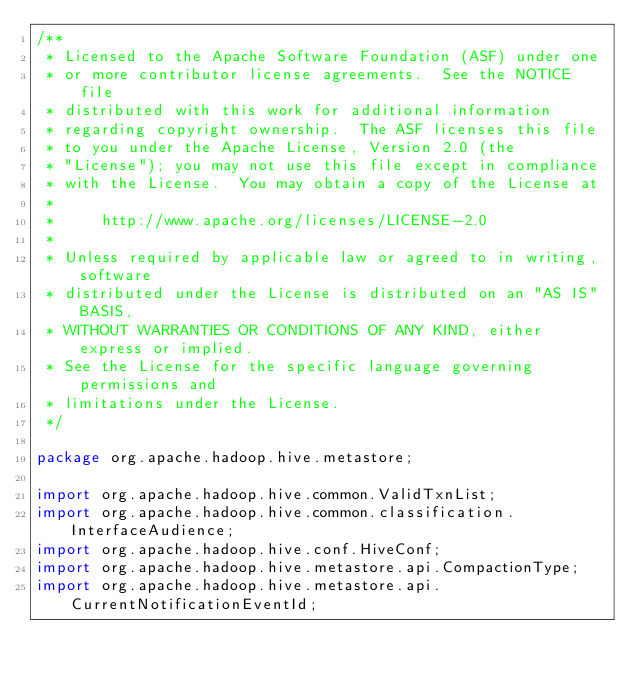Convert code to text. <code><loc_0><loc_0><loc_500><loc_500><_Java_>/**
 * Licensed to the Apache Software Foundation (ASF) under one
 * or more contributor license agreements.  See the NOTICE file
 * distributed with this work for additional information
 * regarding copyright ownership.  The ASF licenses this file
 * to you under the Apache License, Version 2.0 (the
 * "License"); you may not use this file except in compliance
 * with the License.  You may obtain a copy of the License at
 *
 *     http://www.apache.org/licenses/LICENSE-2.0
 *
 * Unless required by applicable law or agreed to in writing, software
 * distributed under the License is distributed on an "AS IS" BASIS,
 * WITHOUT WARRANTIES OR CONDITIONS OF ANY KIND, either express or implied.
 * See the License for the specific language governing permissions and
 * limitations under the License.
 */

package org.apache.hadoop.hive.metastore;

import org.apache.hadoop.hive.common.ValidTxnList;
import org.apache.hadoop.hive.common.classification.InterfaceAudience;
import org.apache.hadoop.hive.conf.HiveConf;
import org.apache.hadoop.hive.metastore.api.CompactionType;
import org.apache.hadoop.hive.metastore.api.CurrentNotificationEventId;</code> 